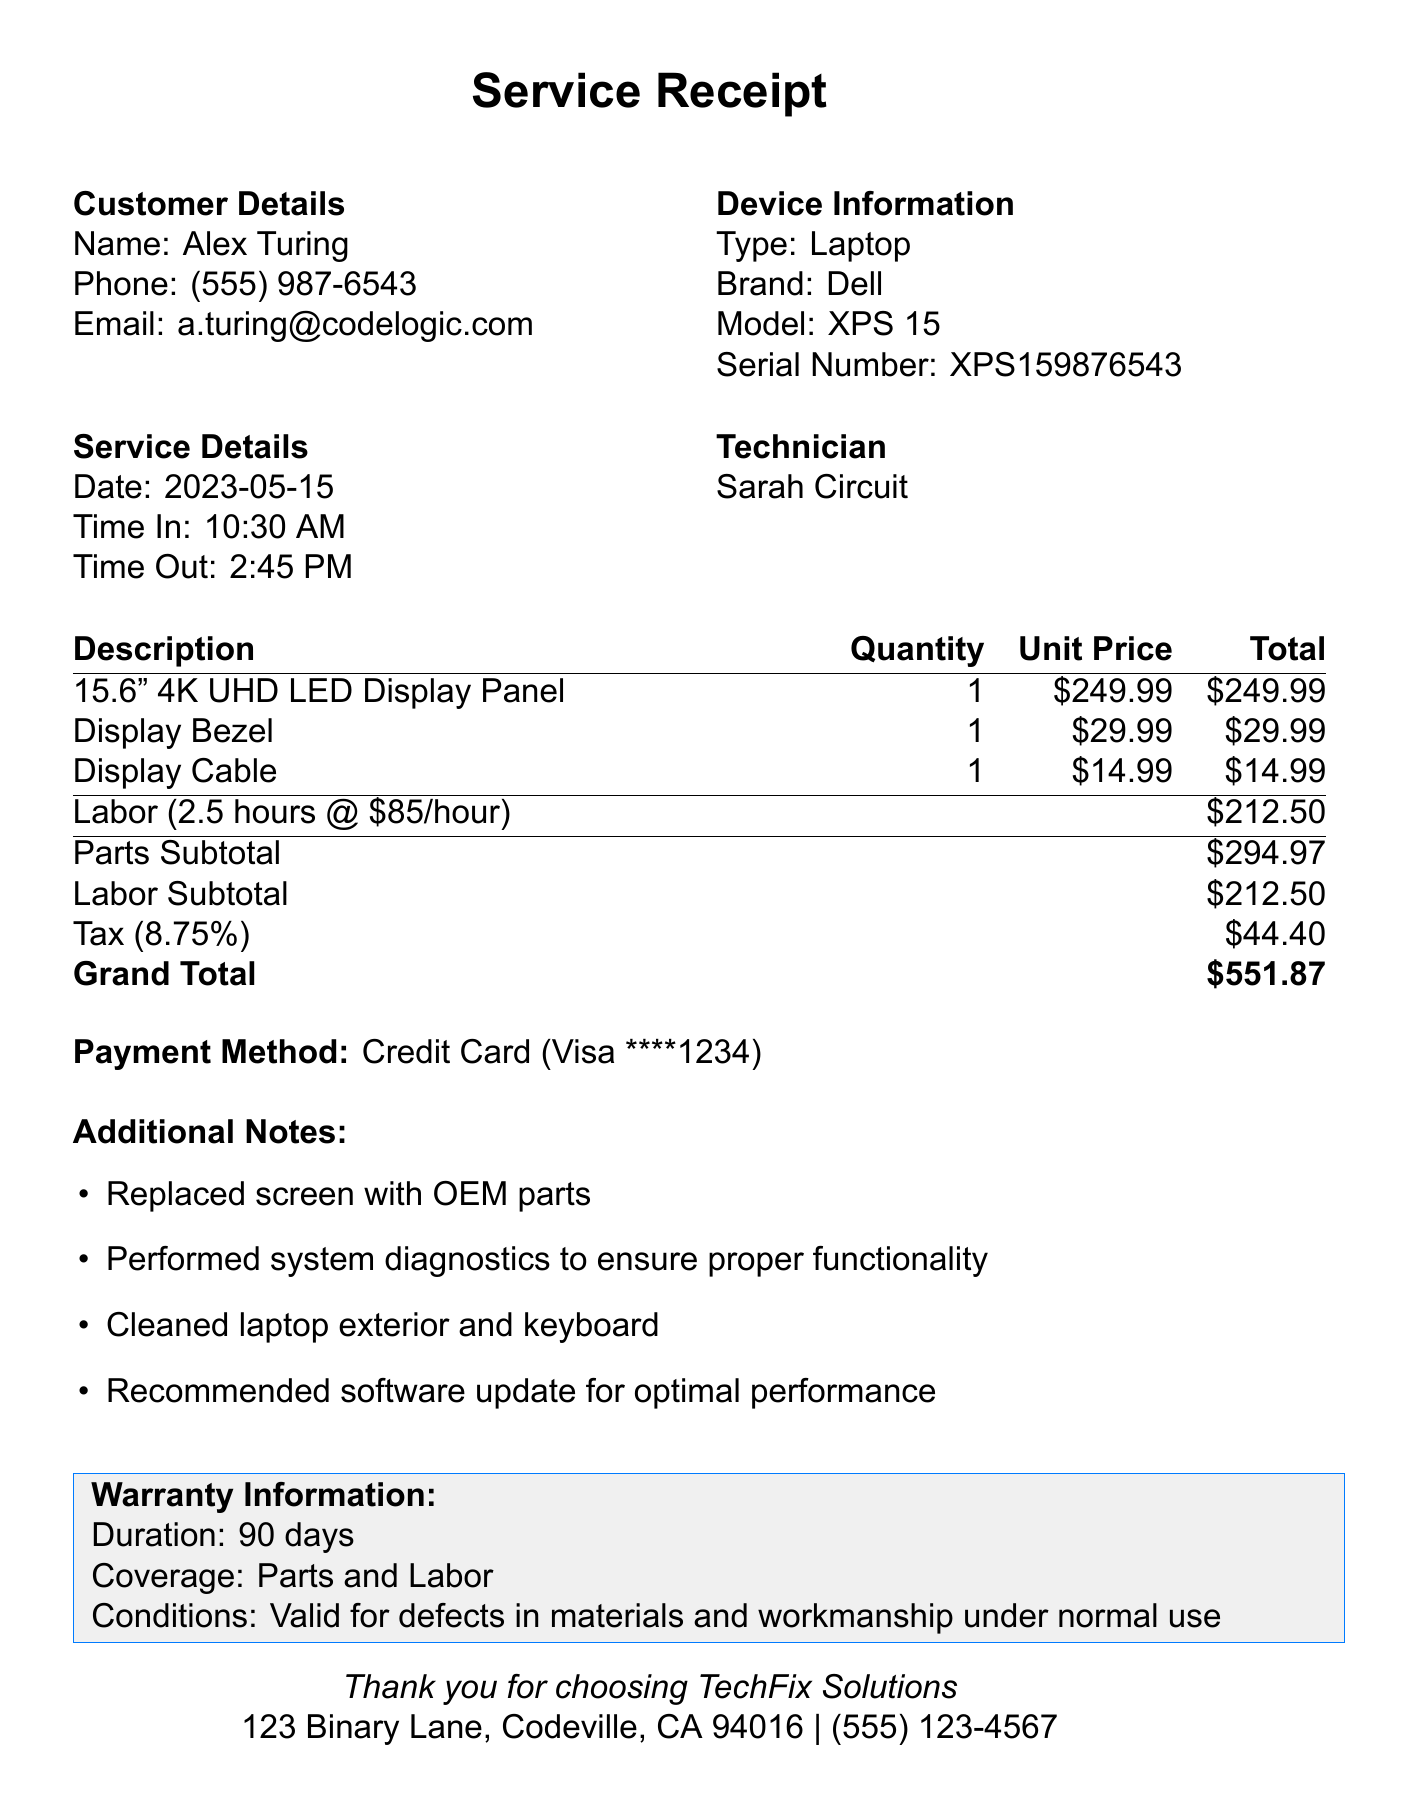what is the name of the repair shop? The repair shop is identified at the top of the document as TechFix Solutions.
Answer: TechFix Solutions who was the technician for the service? The document specifies that the technician who performed the service was Sarah Circuit.
Answer: Sarah Circuit what date was the service performed? The date is listed in the service details section of the document, which states May 15, 2023.
Answer: 2023-05-15 what is the quantity of the Display Bezel? The quantity for the Display Bezel is provided in the parts section, which states there is 1 unit.
Answer: 1 what is the labor cost for the service? The labor cost is explicitly mentioned in the totals section, which states the labor subtotal is $212.50.
Answer: $212.50 how much was charged for tax? The tax amount is detailed in the totals section and is listed as $44.40.
Answer: $44.40 what is the warranty duration for the service? The warranty duration is given in the warranty information section, which states it is for 90 days.
Answer: 90 days what payment method was used? The payment method is indicated in the payment section of the document as Credit Card.
Answer: Credit Card why might the customer be skeptical about the software update? The customer feedback section contains a comment questioning whether the recommended software update is necessary, implying skepticism about upselling.
Answer: Upsell tactic 